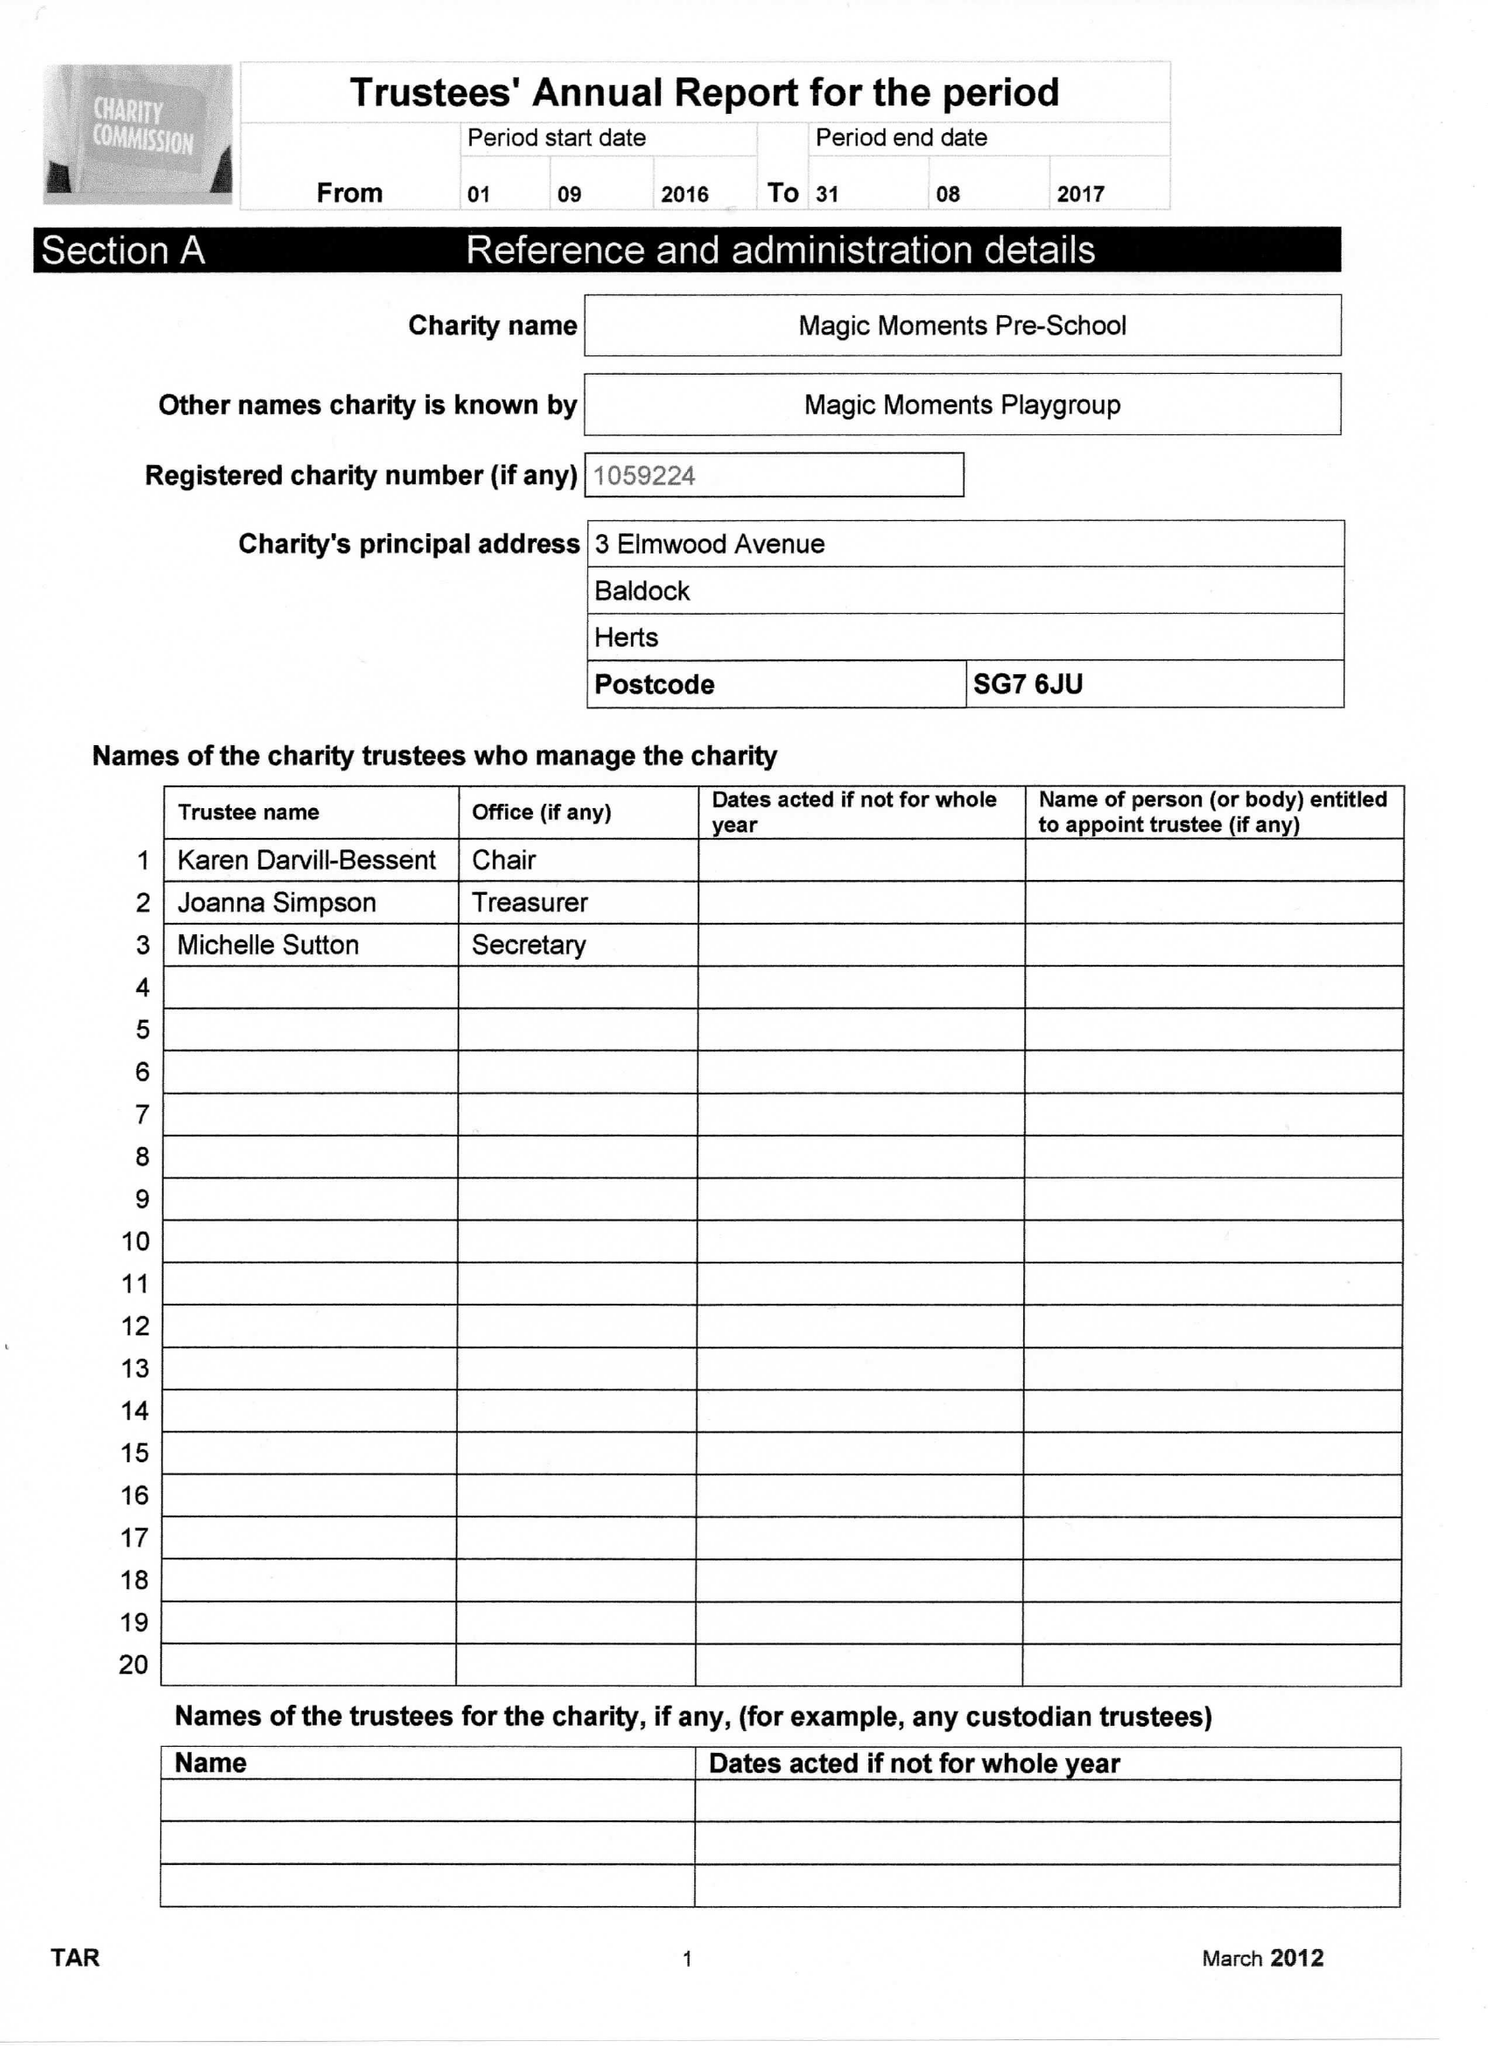What is the value for the address__postcode?
Answer the question using a single word or phrase. SG7 6JU 